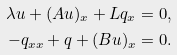Convert formula to latex. <formula><loc_0><loc_0><loc_500><loc_500>\lambda u + ( A u ) _ { x } + L q _ { x } & = 0 , \\ - q _ { x x } + q + ( B u ) _ { x } & = 0 .</formula> 